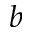<formula> <loc_0><loc_0><loc_500><loc_500>^ { b }</formula> 